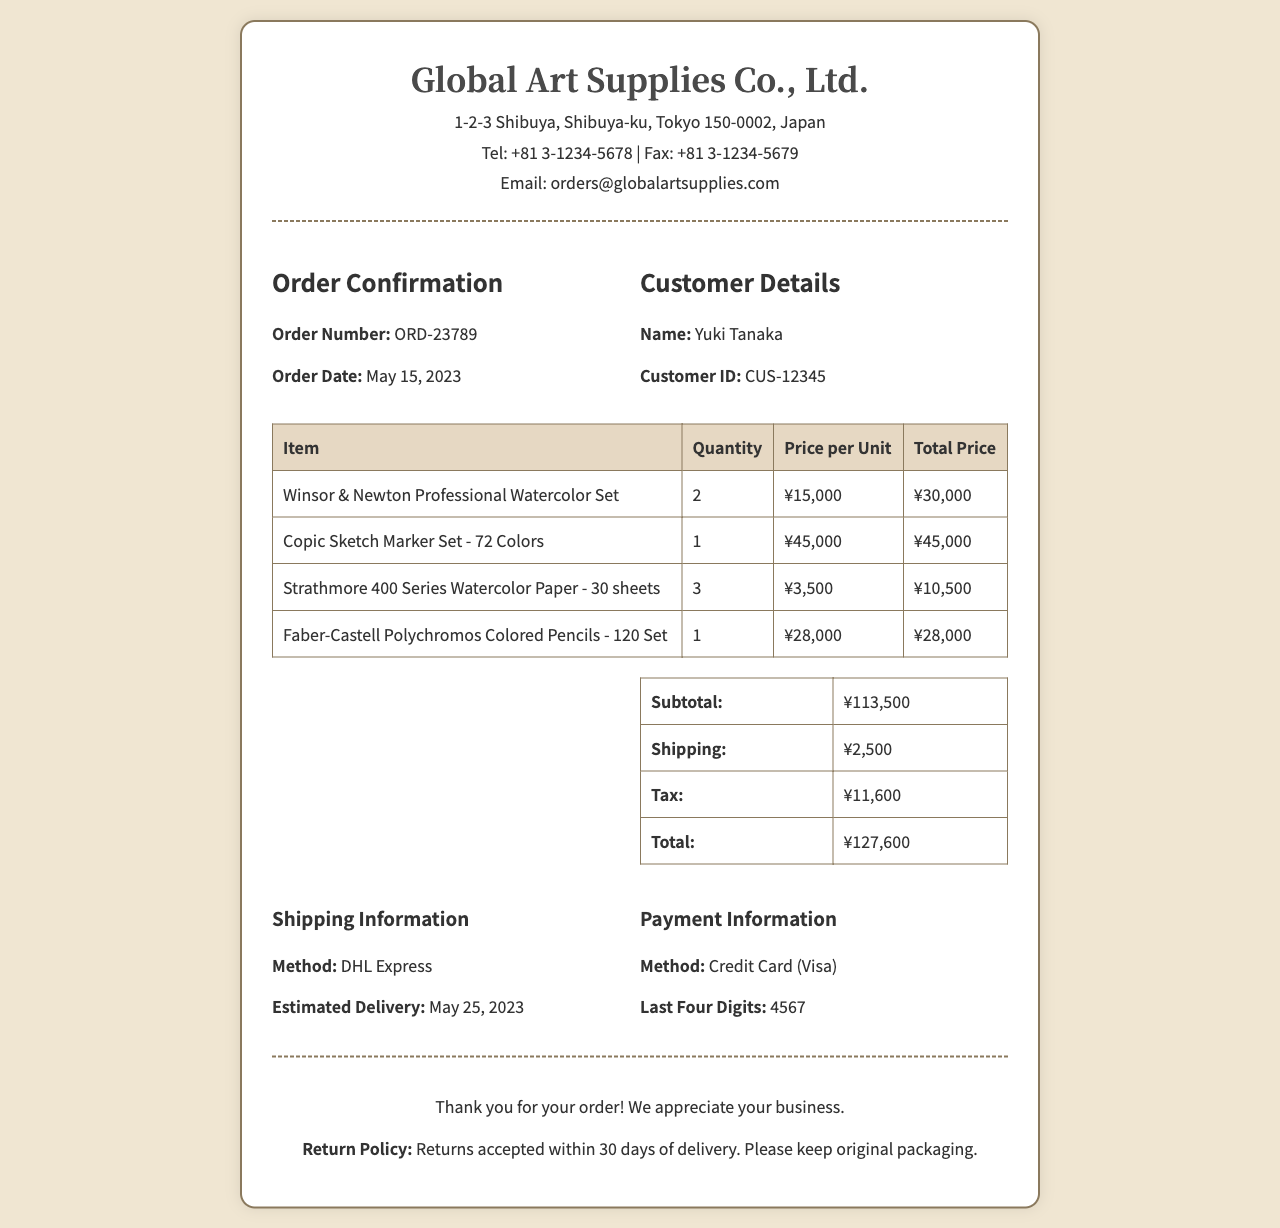What is the order number? The order number is clearly stated in the document under Order Confirmation, which shows "ORD-23789".
Answer: ORD-23789 Who is the customer? The customer details list the name as Yuki Tanaka.
Answer: Yuki Tanaka What is the shipping method? The document specifies "DHL Express" as the shipping method.
Answer: DHL Express What is the total price of the order? The total price is indicated in the order summary, showing ¥127,600.
Answer: ¥127,600 When was the order placed? The order date is stated as May 15, 2023, in the order details section.
Answer: May 15, 2023 How many quantities of Strathmore 400 Series Watercolor Paper were ordered? The table lists the quantity for Strathmore 400 Series Watercolor Paper as "3".
Answer: 3 What is the estimated delivery date? The document mentions "May 25, 2023" as the estimated delivery date.
Answer: May 25, 2023 What is the price per unit of Copic Sketch Marker Set? The price per unit for the Copic Sketch Marker Set is shown as ¥45,000 in the table.
Answer: ¥45,000 